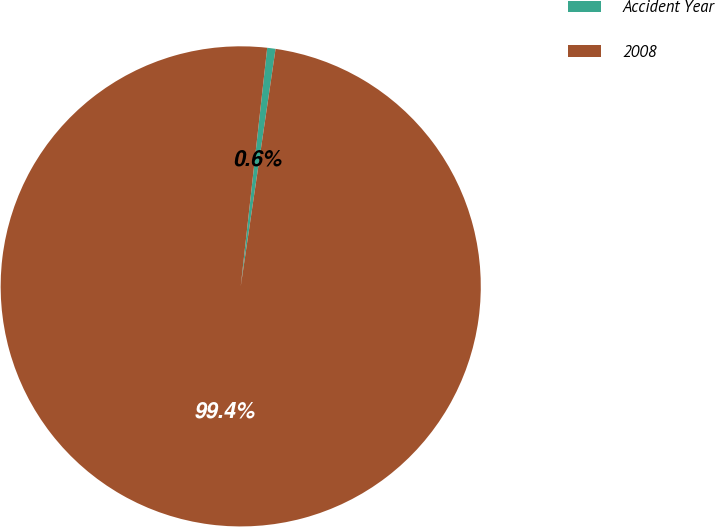Convert chart. <chart><loc_0><loc_0><loc_500><loc_500><pie_chart><fcel>Accident Year<fcel>2008<nl><fcel>0.56%<fcel>99.44%<nl></chart> 